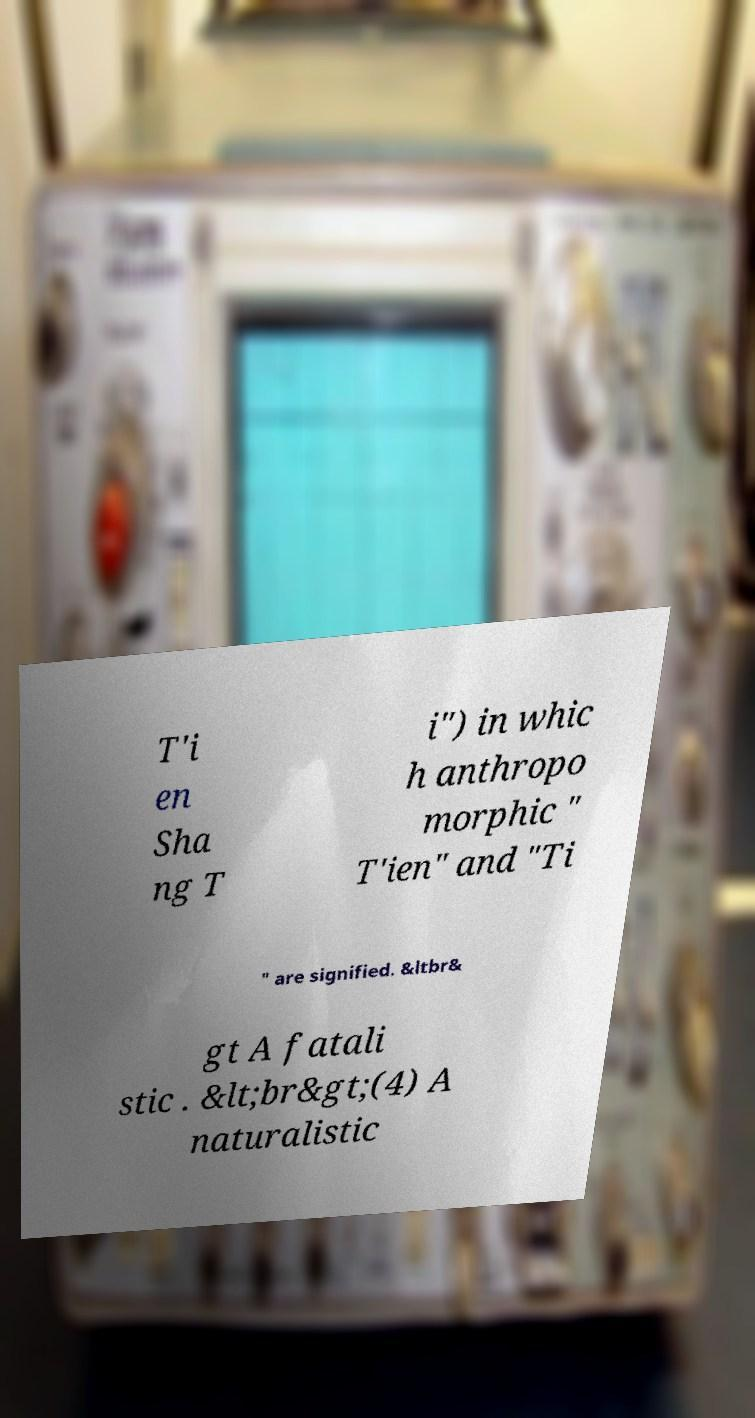Can you read and provide the text displayed in the image?This photo seems to have some interesting text. Can you extract and type it out for me? T'i en Sha ng T i") in whic h anthropo morphic " T'ien" and "Ti " are signified. &ltbr& gt A fatali stic . &lt;br&gt;(4) A naturalistic 